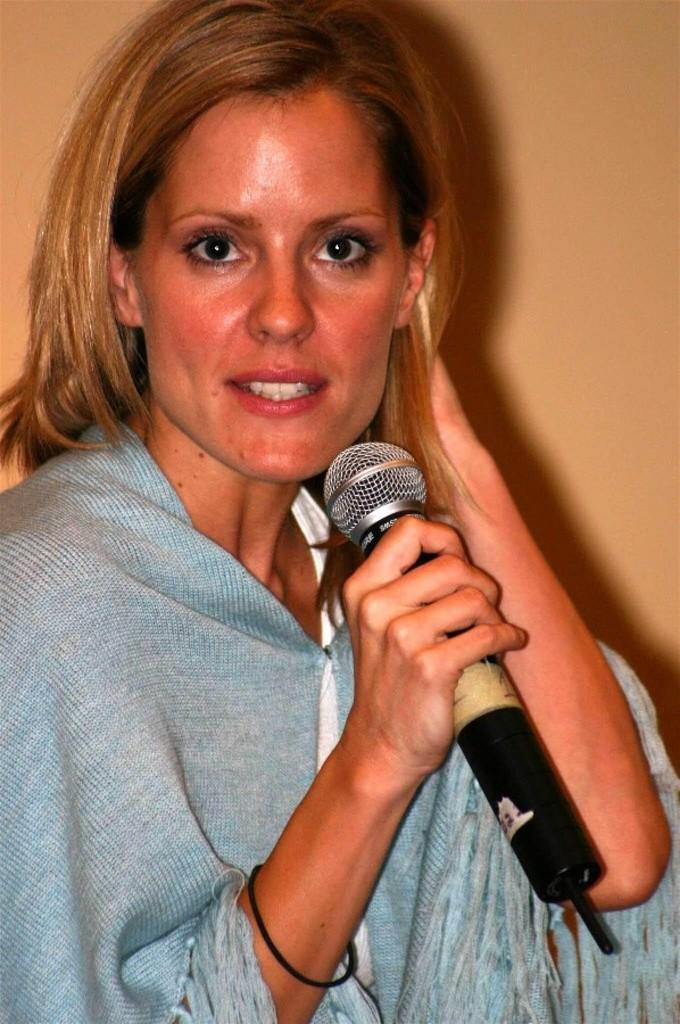Who is the main subject in the image? There is a lady in the image. Can you describe the lady's appearance? The lady has short hair. What is on the lady's right hand? The lady has a black band on her right hand. What is the lady holding in her right hand? The lady is holding a mic in her right hand. How many bears are visible in the image? There are no bears present in the image. What color is the expansion in the image? There is no expansion present in the image, and therefore no color can be assigned to it. 